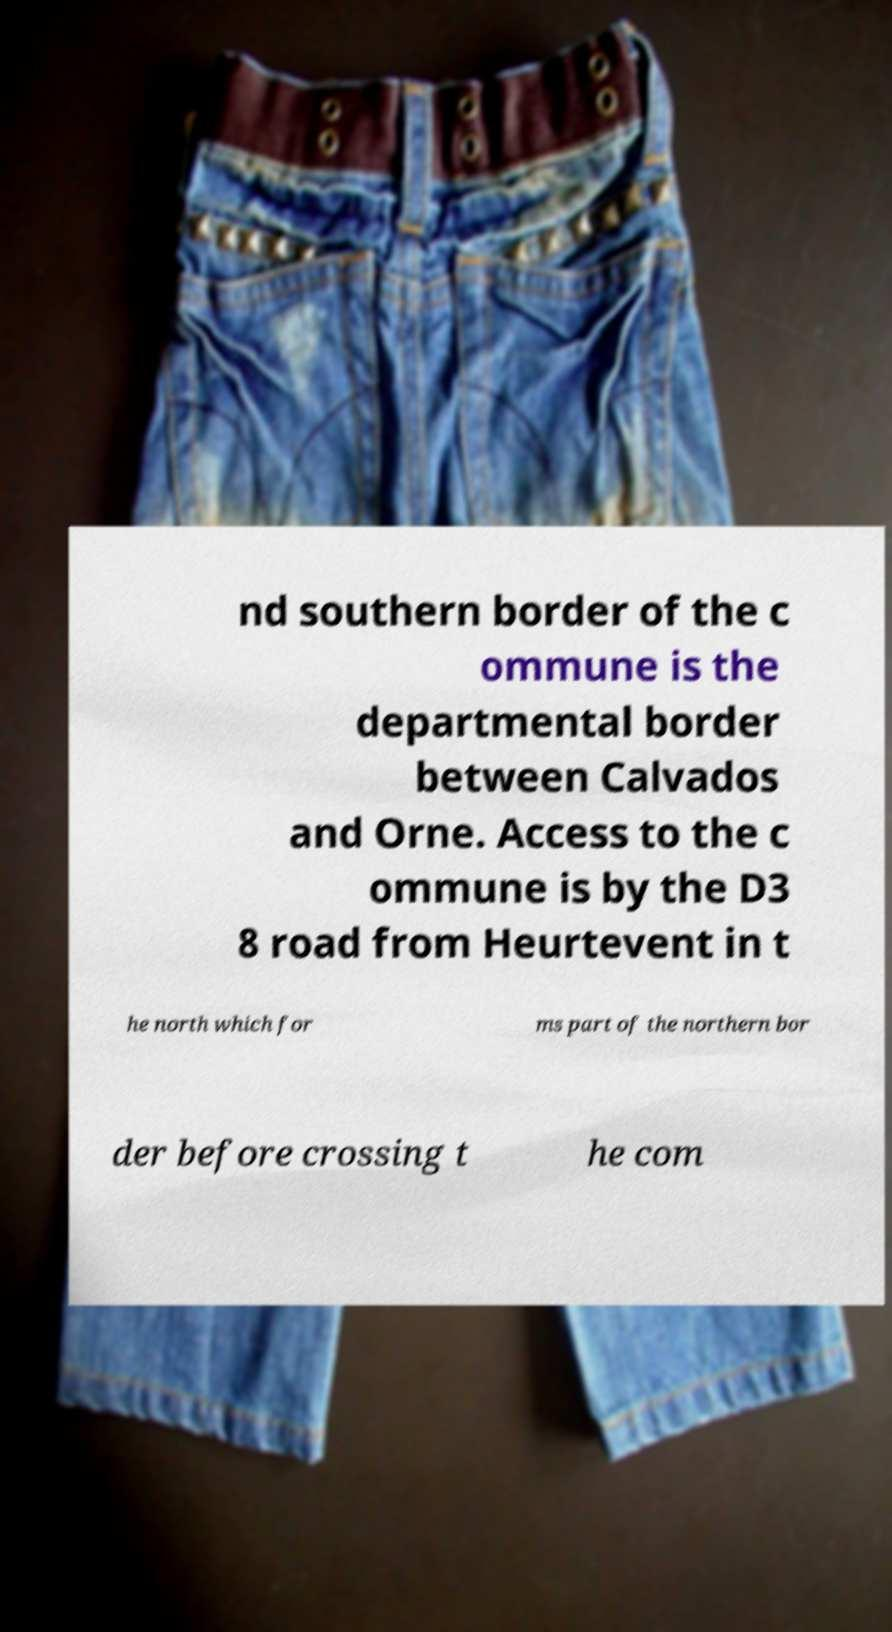Can you accurately transcribe the text from the provided image for me? nd southern border of the c ommune is the departmental border between Calvados and Orne. Access to the c ommune is by the D3 8 road from Heurtevent in t he north which for ms part of the northern bor der before crossing t he com 